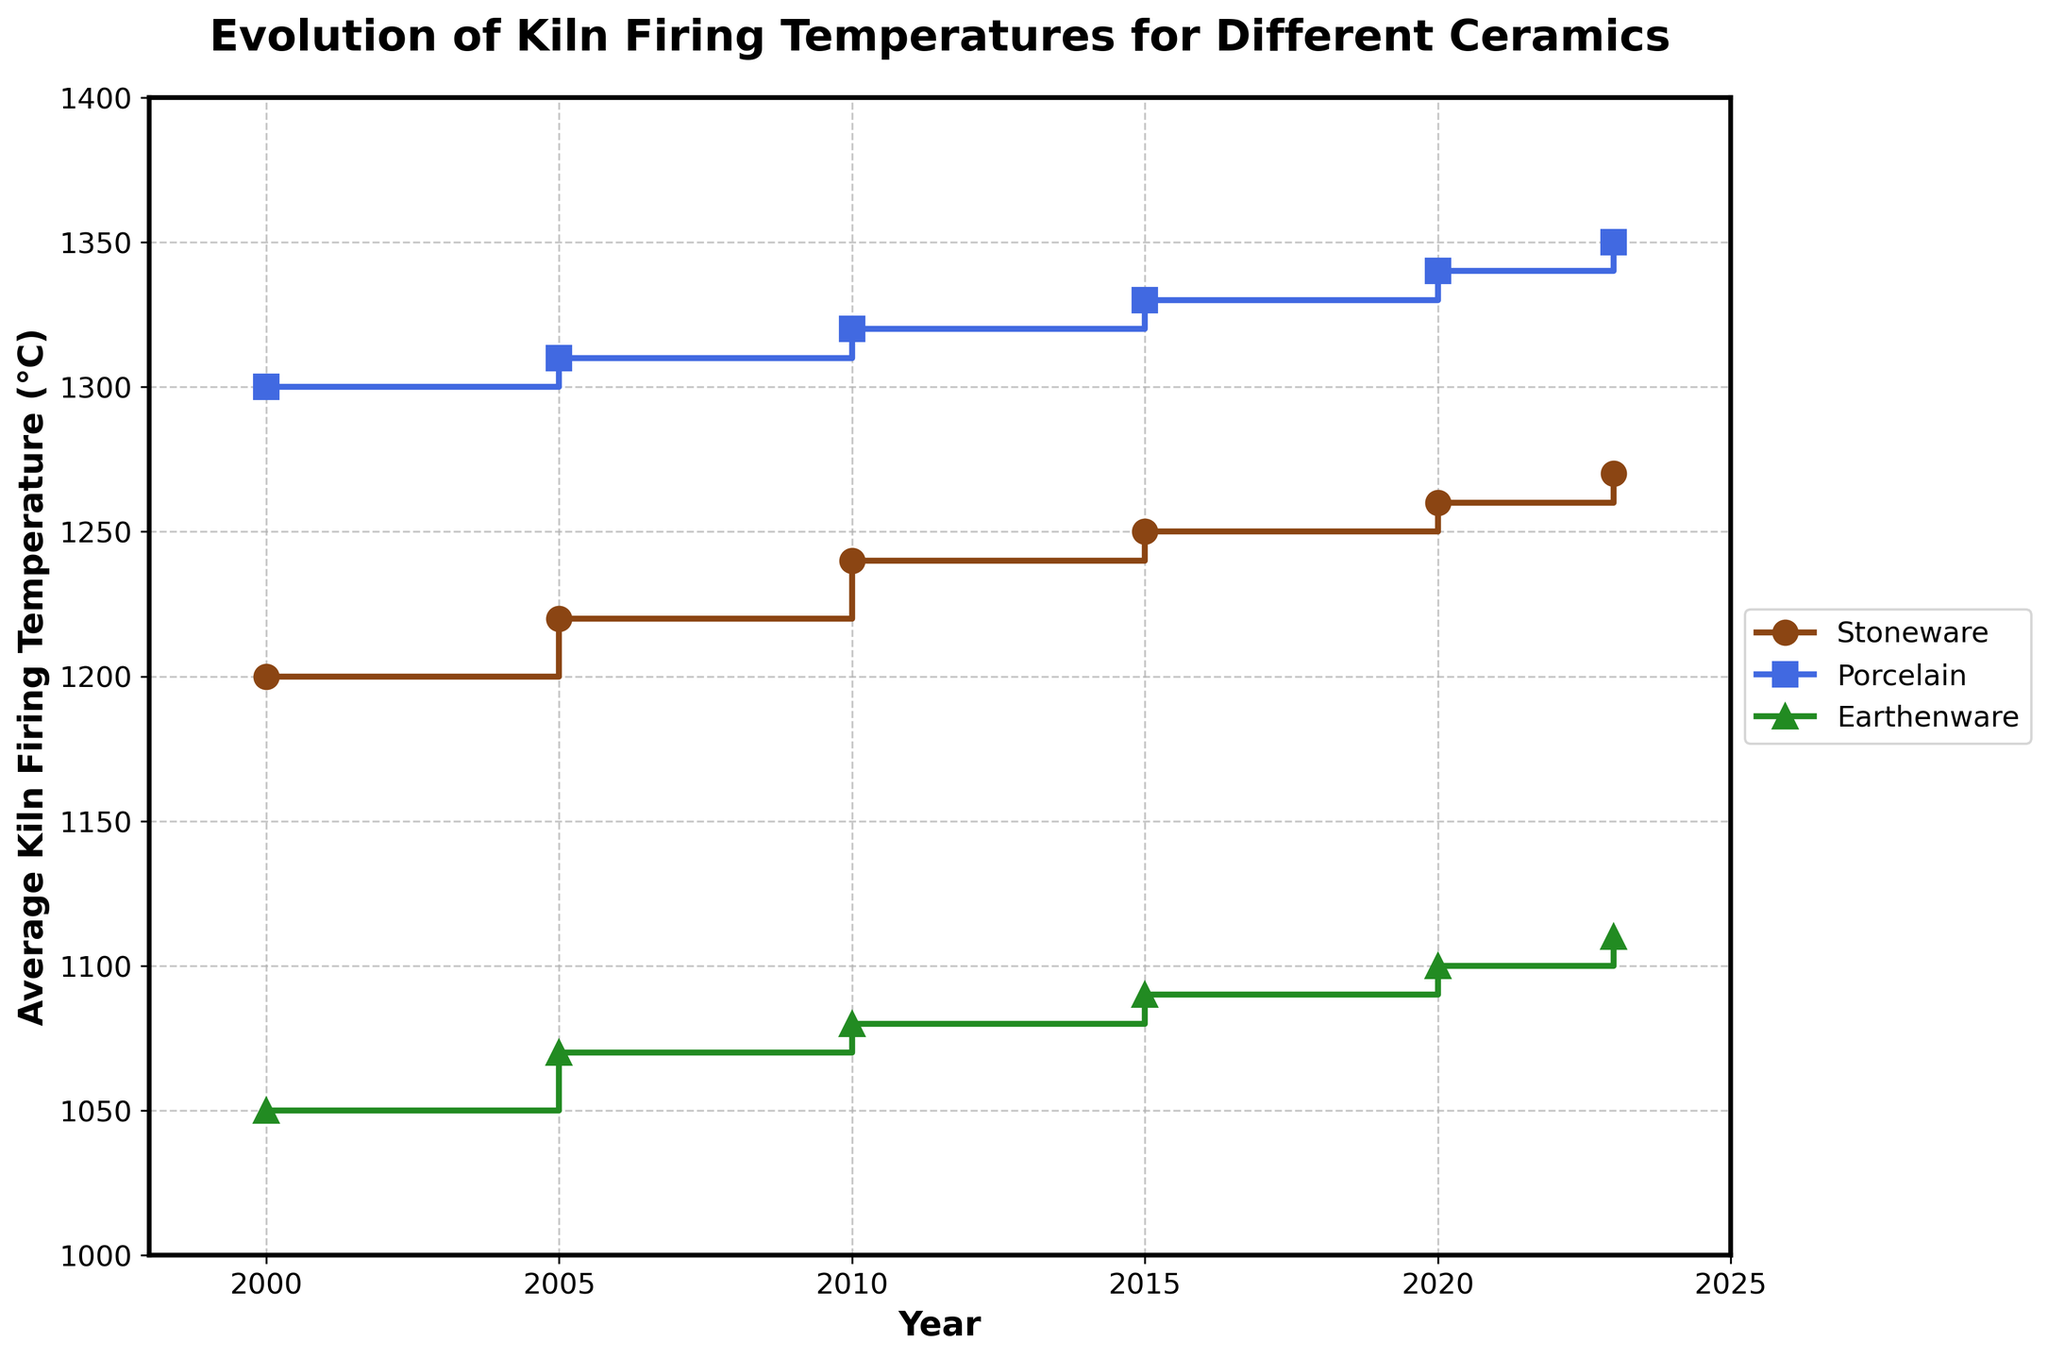Which type of ceramic had the highest firing temperature in the year 2020? To find this, look at the data points for 2020 and compare the firing temperatures for Stoneware, Porcelain, and Earthenware. The highest value among them belongs to the type of ceramic with the highest firing temperature. Porcelain had the highest firing temperature of 1340°C in 2020.
Answer: Porcelain What's the average kiln firing temperature for Stoneware across all the years in the plot? To find the average, add the firing temperatures for Stoneware for all the years (1200, 1220, 1240, 1250, 1260, and 1270) and divide by the number of years (6). (1200 + 1220 + 1240 + 1250 + 1260 + 1270) / 6 = 7440 / 6 = 1240°C.
Answer: 1240°C How much did the firing temperature for Earthenware increase from the year 2000 to 2023? Calculate the difference between the firing temperatures in 2023 and 2000 for Earthenware. 1110°C (2023) - 1050°C (2000) = 60°C increase.
Answer: 60°C Is there a year where the firing temperatures for all three types of ceramics increased compared to the previous period? Examine each stair segment to see if, in any given year, all three types of ceramics show an increase compared to the previous period. This is true for all years depicted from 2000 to 2023 as each segment shows an upward step.
Answer: Yes, in every period from 2000 to 2023 Which type of ceramic showed the least overall change in firing temperature from 2000 to 2023? Calculate the change in firing temperature for each ceramic type from 2000 to 2023. The changes are: 
   - Stoneware: 1270°C - 1200°C = 70°C 
   - Porcelain: 1350°C - 1300°C = 50°C
   - Earthenware: 1110°C - 1050°C = 60°C
The smallest change is for Porcelain at 50°C.
Answer: Porcelain What is the temperature difference between Stoneware and Porcelain in the year 2015? Look at the firing temperatures for Stoneware and Porcelain for the year 2015. Calculate the difference: 1330°C (Porcelain) - 1250°C (Stoneware) = 80°C.
Answer: 80°C Between which consecutive years did Porcelain see the highest growth in firing temperature? Evaluate the difference in firing temperatures for Porcelain between consecutive years. The increases are:
   - 2000 to 2005: 1310°C - 1300°C = 10°C
   - 2005 to 2010: 1320°C - 1310°C = 10°C
   - 2010 to 2015: 1330°C - 1320°C = 10°C
   - 2015 to 2020: 1340°C - 1330°C = 10°C
   - 2020 to 2023: 1350°C - 1340°C = 10°C
Hence, the highest growth is consistent at 10°C between all consecutive intervals.
Answer: 2000 to 2005 (or any consecutive period) What is the total increase in firing temperature for Stoneware and Earthenware combined between 2000 and 2023? Calculate the increase for each:
   - Stoneware: 1270°C (2023) -1200°C (2000) = 70°C
   - Earthenware: 1110°C (2023) - 1050°C (2000) = 60°C
Add both: 70°C + 60°C = 130°C
Answer: 130°C 